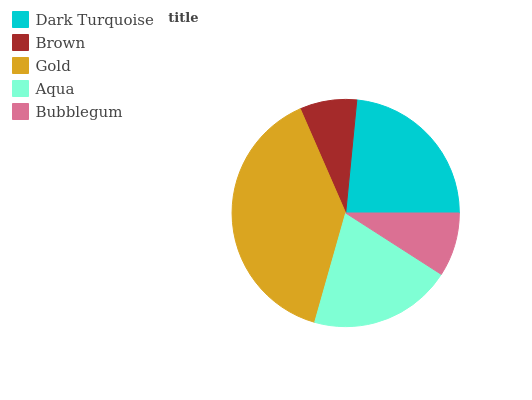Is Brown the minimum?
Answer yes or no. Yes. Is Gold the maximum?
Answer yes or no. Yes. Is Gold the minimum?
Answer yes or no. No. Is Brown the maximum?
Answer yes or no. No. Is Gold greater than Brown?
Answer yes or no. Yes. Is Brown less than Gold?
Answer yes or no. Yes. Is Brown greater than Gold?
Answer yes or no. No. Is Gold less than Brown?
Answer yes or no. No. Is Aqua the high median?
Answer yes or no. Yes. Is Aqua the low median?
Answer yes or no. Yes. Is Gold the high median?
Answer yes or no. No. Is Gold the low median?
Answer yes or no. No. 